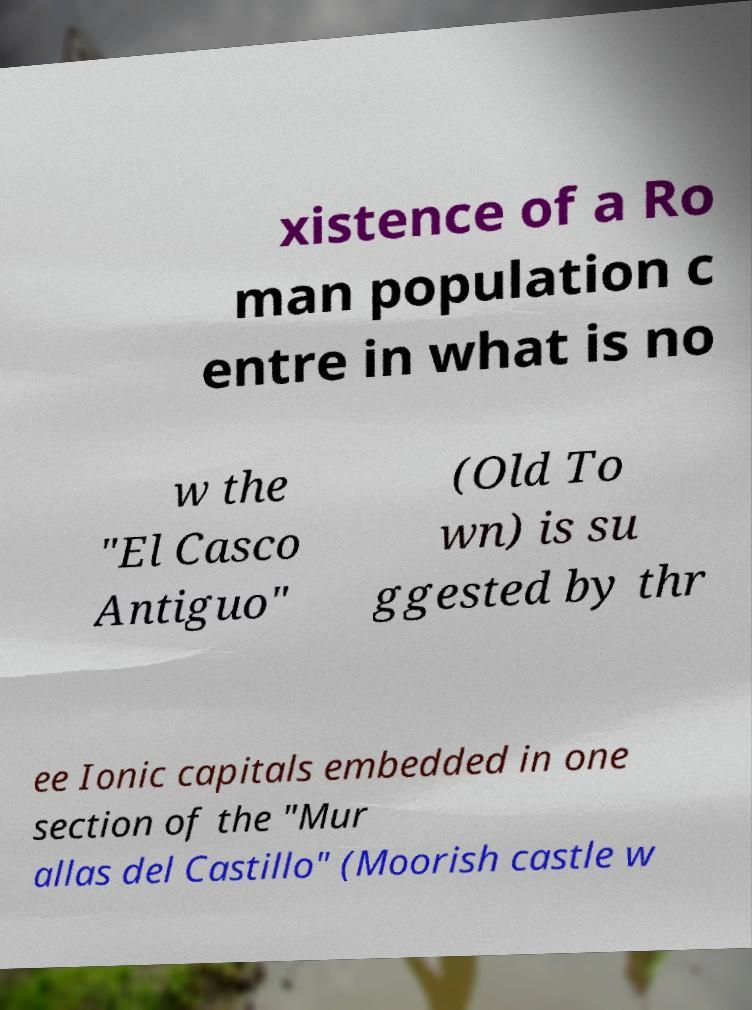Could you assist in decoding the text presented in this image and type it out clearly? xistence of a Ro man population c entre in what is no w the "El Casco Antiguo" (Old To wn) is su ggested by thr ee Ionic capitals embedded in one section of the "Mur allas del Castillo" (Moorish castle w 